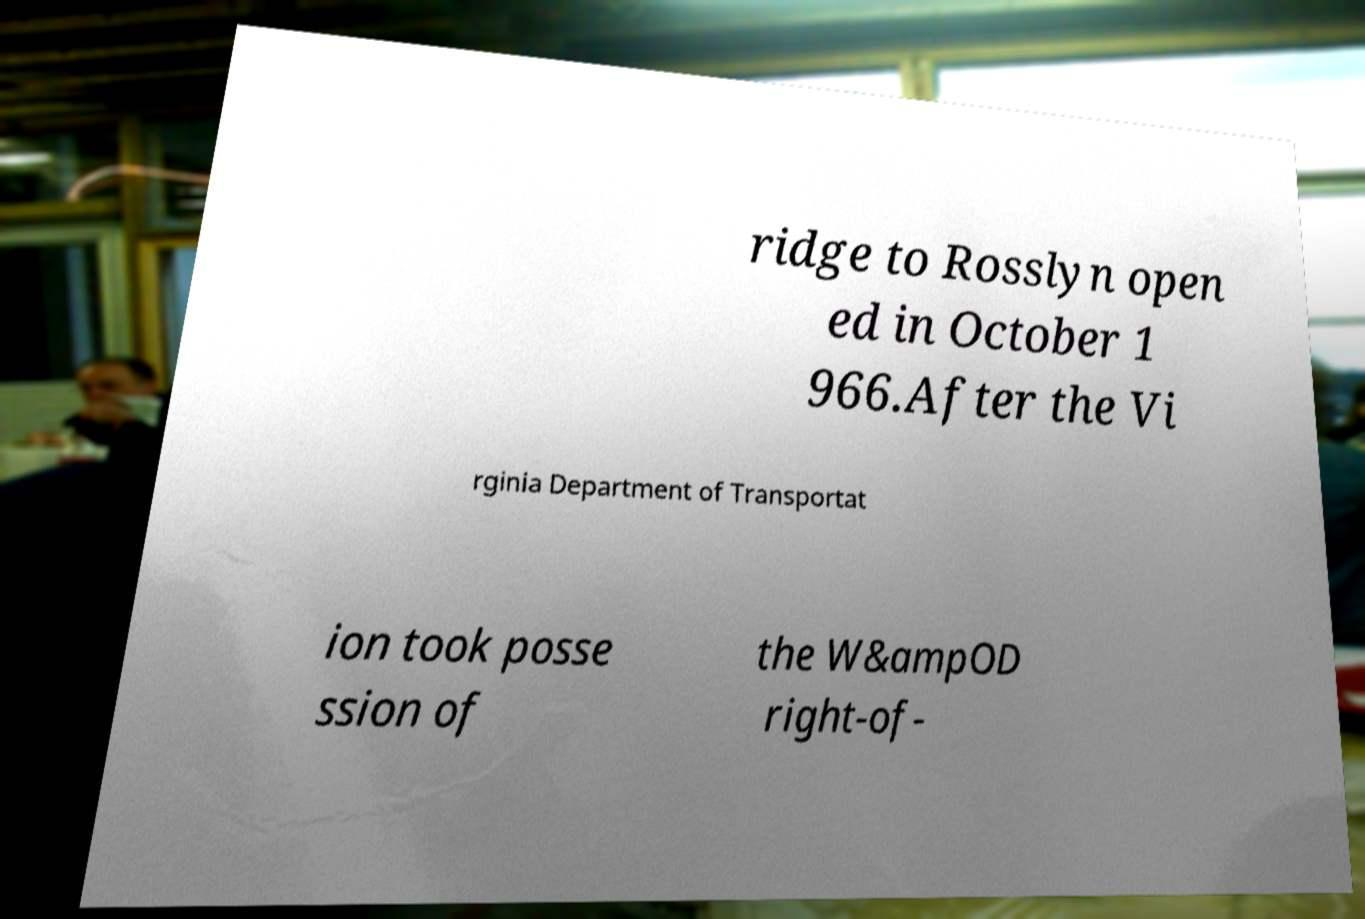There's text embedded in this image that I need extracted. Can you transcribe it verbatim? ridge to Rosslyn open ed in October 1 966.After the Vi rginia Department of Transportat ion took posse ssion of the W&ampOD right-of- 